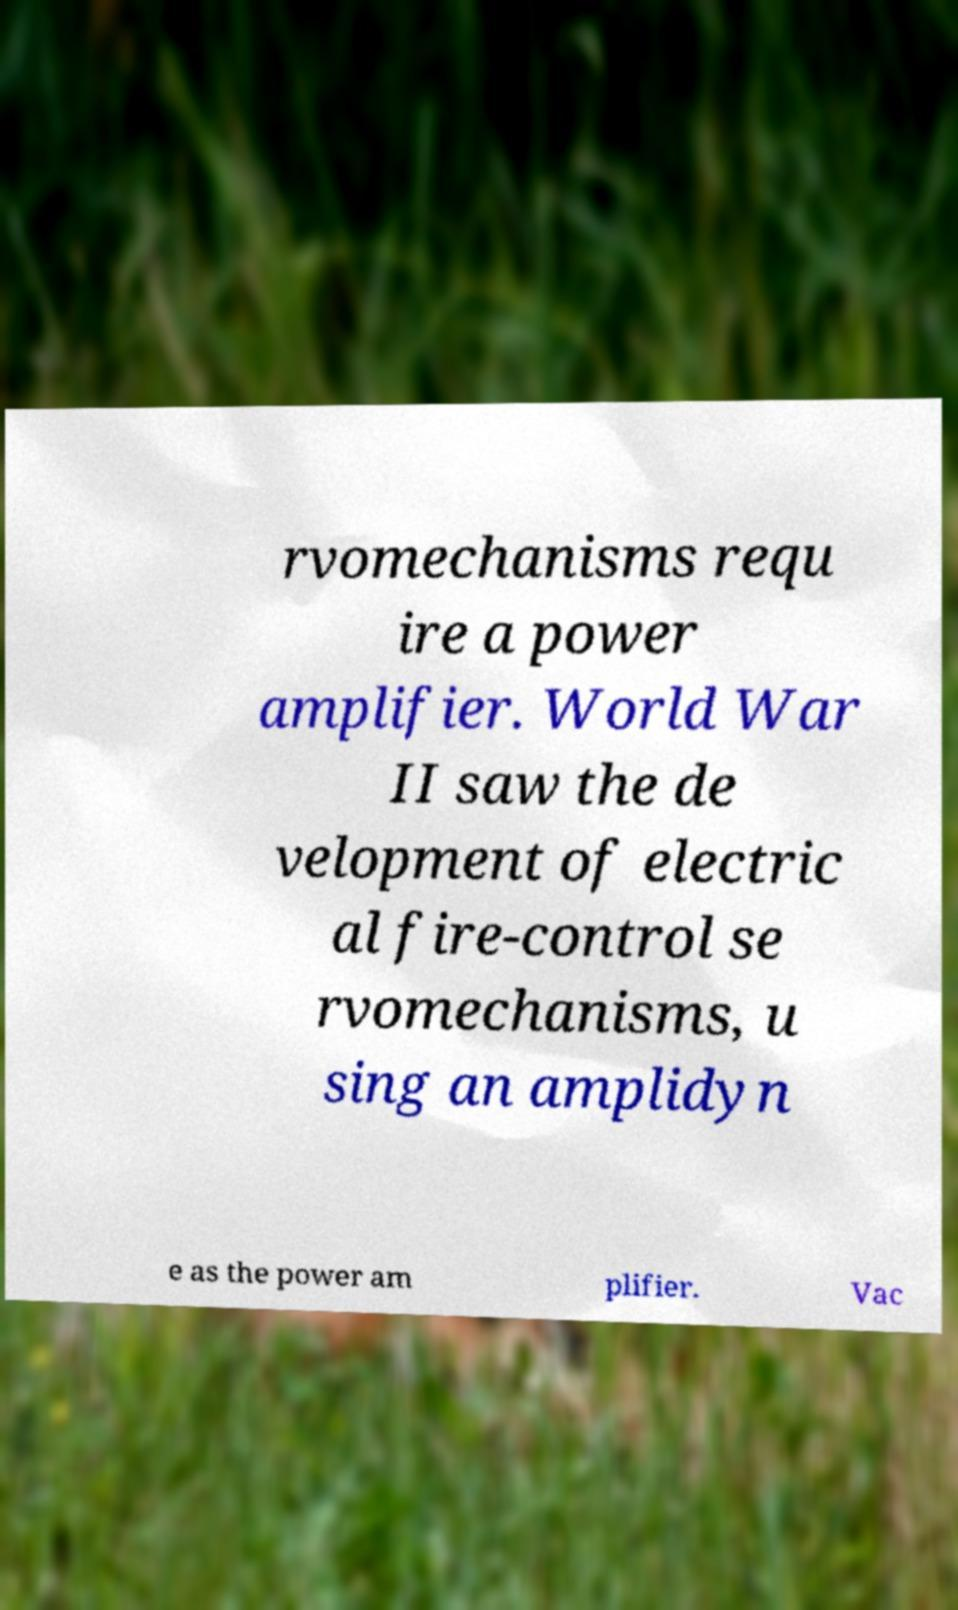What messages or text are displayed in this image? I need them in a readable, typed format. rvomechanisms requ ire a power amplifier. World War II saw the de velopment of electric al fire-control se rvomechanisms, u sing an amplidyn e as the power am plifier. Vac 